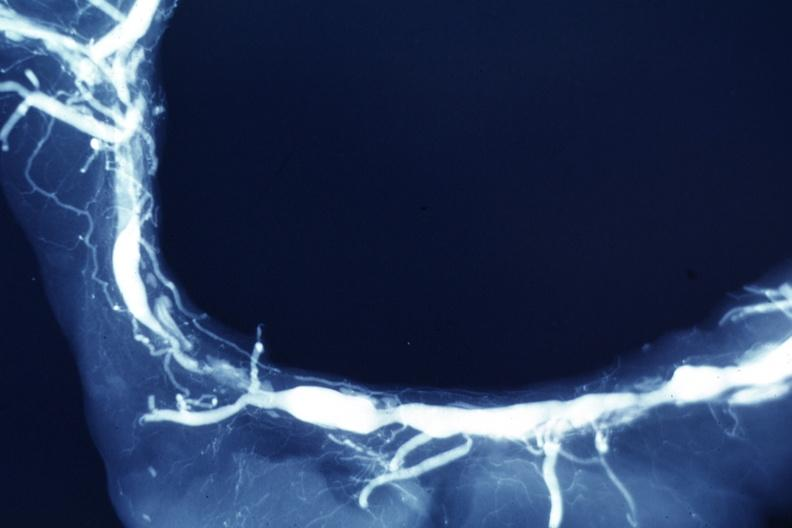s coronary artery present?
Answer the question using a single word or phrase. Yes 